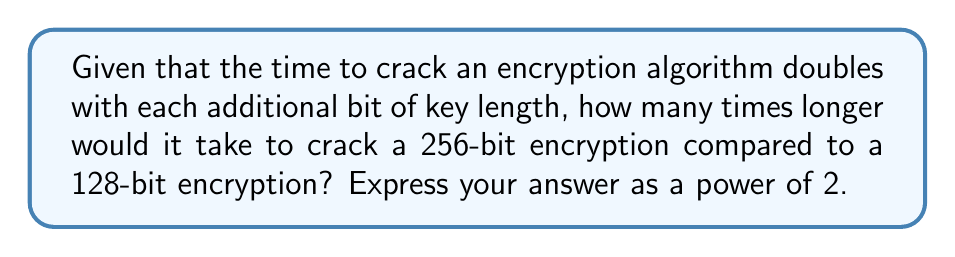Help me with this question. To solve this problem, we need to follow these steps:

1. Calculate the difference in key length:
   $256 - 128 = 128$ bits

2. Understand that each additional bit doubles the time to crack:
   This means we need to double the time 128 times.

3. Express this mathematically:
   $2^{128}$

This result means that a 256-bit encryption would take $2^{128}$ times longer to crack than a 128-bit encryption.

For our lobbying purposes, we can use this to argue that 256-bit encryption provides an astronomically higher level of security compared to 128-bit encryption. This could be used to advocate for or against certain encryption standards, depending on our agenda.
Answer: $2^{128}$ 